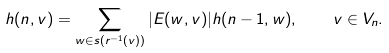Convert formula to latex. <formula><loc_0><loc_0><loc_500><loc_500>h ( n , v ) = \sum _ { w \in s ( r ^ { - 1 } ( v ) ) } | E ( w , v ) | h ( n - 1 , w ) , \quad v \in V _ { n } .</formula> 